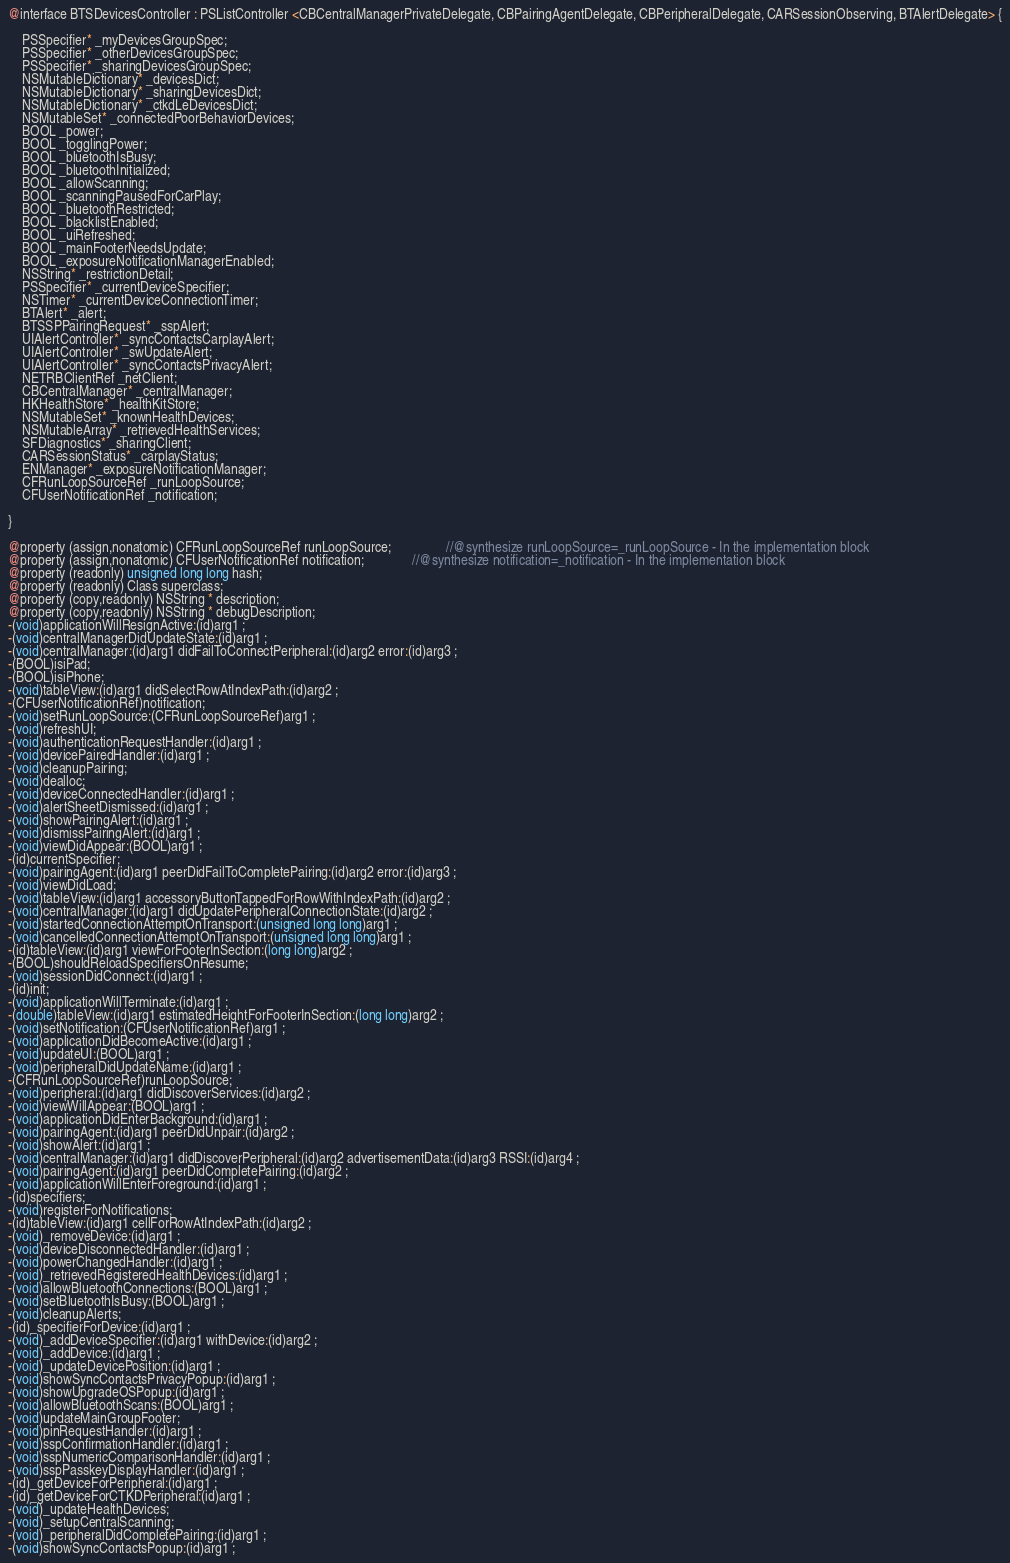<code> <loc_0><loc_0><loc_500><loc_500><_C_>@interface BTSDevicesController : PSListController <CBCentralManagerPrivateDelegate, CBPairingAgentDelegate, CBPeripheralDelegate, CARSessionObserving, BTAlertDelegate> {

	PSSpecifier* _myDevicesGroupSpec;
	PSSpecifier* _otherDevicesGroupSpec;
	PSSpecifier* _sharingDevicesGroupSpec;
	NSMutableDictionary* _devicesDict;
	NSMutableDictionary* _sharingDevicesDict;
	NSMutableDictionary* _ctkdLeDevicesDict;
	NSMutableSet* _connectedPoorBehaviorDevices;
	BOOL _power;
	BOOL _togglingPower;
	BOOL _bluetoothIsBusy;
	BOOL _bluetoothInitialized;
	BOOL _allowScanning;
	BOOL _scanningPausedForCarPlay;
	BOOL _bluetoothRestricted;
	BOOL _blacklistEnabled;
	BOOL _uiRefreshed;
	BOOL _mainFooterNeedsUpdate;
	BOOL _exposureNotificationManagerEnabled;
	NSString* _restrictionDetail;
	PSSpecifier* _currentDeviceSpecifier;
	NSTimer* _currentDeviceConnectionTimer;
	BTAlert* _alert;
	BTSSPPairingRequest* _sspAlert;
	UIAlertController* _syncContactsCarplayAlert;
	UIAlertController* _swUpdateAlert;
	UIAlertController* _syncContactsPrivacyAlert;
	NETRBClientRef _netClient;
	CBCentralManager* _centralManager;
	HKHealthStore* _healthKitStore;
	NSMutableSet* _knownHealthDevices;
	NSMutableArray* _retrievedHealthServices;
	SFDiagnostics* _sharingClient;
	CARSessionStatus* _carplayStatus;
	ENManager* _exposureNotificationManager;
	CFRunLoopSourceRef _runLoopSource;
	CFUserNotificationRef _notification;

}

@property (assign,nonatomic) CFRunLoopSourceRef runLoopSource;                //@synthesize runLoopSource=_runLoopSource - In the implementation block
@property (assign,nonatomic) CFUserNotificationRef notification;              //@synthesize notification=_notification - In the implementation block
@property (readonly) unsigned long long hash; 
@property (readonly) Class superclass; 
@property (copy,readonly) NSString * description; 
@property (copy,readonly) NSString * debugDescription; 
-(void)applicationWillResignActive:(id)arg1 ;
-(void)centralManagerDidUpdateState:(id)arg1 ;
-(void)centralManager:(id)arg1 didFailToConnectPeripheral:(id)arg2 error:(id)arg3 ;
-(BOOL)isiPad;
-(BOOL)isiPhone;
-(void)tableView:(id)arg1 didSelectRowAtIndexPath:(id)arg2 ;
-(CFUserNotificationRef)notification;
-(void)setRunLoopSource:(CFRunLoopSourceRef)arg1 ;
-(void)refreshUI;
-(void)authenticationRequestHandler:(id)arg1 ;
-(void)devicePairedHandler:(id)arg1 ;
-(void)cleanupPairing;
-(void)dealloc;
-(void)deviceConnectedHandler:(id)arg1 ;
-(void)alertSheetDismissed:(id)arg1 ;
-(void)showPairingAlert:(id)arg1 ;
-(void)dismissPairingAlert:(id)arg1 ;
-(void)viewDidAppear:(BOOL)arg1 ;
-(id)currentSpecifier;
-(void)pairingAgent:(id)arg1 peerDidFailToCompletePairing:(id)arg2 error:(id)arg3 ;
-(void)viewDidLoad;
-(void)tableView:(id)arg1 accessoryButtonTappedForRowWithIndexPath:(id)arg2 ;
-(void)centralManager:(id)arg1 didUpdatePeripheralConnectionState:(id)arg2 ;
-(void)startedConnectionAttemptOnTransport:(unsigned long long)arg1 ;
-(void)cancelledConnectionAttemptOnTransport:(unsigned long long)arg1 ;
-(id)tableView:(id)arg1 viewForFooterInSection:(long long)arg2 ;
-(BOOL)shouldReloadSpecifiersOnResume;
-(void)sessionDidConnect:(id)arg1 ;
-(id)init;
-(void)applicationWillTerminate:(id)arg1 ;
-(double)tableView:(id)arg1 estimatedHeightForFooterInSection:(long long)arg2 ;
-(void)setNotification:(CFUserNotificationRef)arg1 ;
-(void)applicationDidBecomeActive:(id)arg1 ;
-(void)updateUI:(BOOL)arg1 ;
-(void)peripheralDidUpdateName:(id)arg1 ;
-(CFRunLoopSourceRef)runLoopSource;
-(void)peripheral:(id)arg1 didDiscoverServices:(id)arg2 ;
-(void)viewWillAppear:(BOOL)arg1 ;
-(void)applicationDidEnterBackground:(id)arg1 ;
-(void)pairingAgent:(id)arg1 peerDidUnpair:(id)arg2 ;
-(void)showAlert:(id)arg1 ;
-(void)centralManager:(id)arg1 didDiscoverPeripheral:(id)arg2 advertisementData:(id)arg3 RSSI:(id)arg4 ;
-(void)pairingAgent:(id)arg1 peerDidCompletePairing:(id)arg2 ;
-(void)applicationWillEnterForeground:(id)arg1 ;
-(id)specifiers;
-(void)registerForNotifications;
-(id)tableView:(id)arg1 cellForRowAtIndexPath:(id)arg2 ;
-(void)_removeDevice:(id)arg1 ;
-(void)deviceDisconnectedHandler:(id)arg1 ;
-(void)powerChangedHandler:(id)arg1 ;
-(void)_retrievedRegisteredHealthDevices:(id)arg1 ;
-(void)allowBluetoothConnections:(BOOL)arg1 ;
-(void)setBluetoothIsBusy:(BOOL)arg1 ;
-(void)cleanupAlerts;
-(id)_specifierForDevice:(id)arg1 ;
-(void)_addDeviceSpecifier:(id)arg1 withDevice:(id)arg2 ;
-(void)_addDevice:(id)arg1 ;
-(void)_updateDevicePosition:(id)arg1 ;
-(void)showSyncContactsPrivacyPopup:(id)arg1 ;
-(void)showUpgradeOSPopup:(id)arg1 ;
-(void)allowBluetoothScans:(BOOL)arg1 ;
-(void)updateMainGroupFooter;
-(void)pinRequestHandler:(id)arg1 ;
-(void)sspConfirmationHandler:(id)arg1 ;
-(void)sspNumericComparisonHandler:(id)arg1 ;
-(void)sspPasskeyDisplayHandler:(id)arg1 ;
-(id)_getDeviceForPeripheral:(id)arg1 ;
-(id)_getDeviceForCTKDPeripheral:(id)arg1 ;
-(void)_updateHealthDevices;
-(void)_setupCentralScanning;
-(void)_peripheralDidCompletePairing:(id)arg1 ;
-(void)showSyncContactsPopup:(id)arg1 ;</code> 